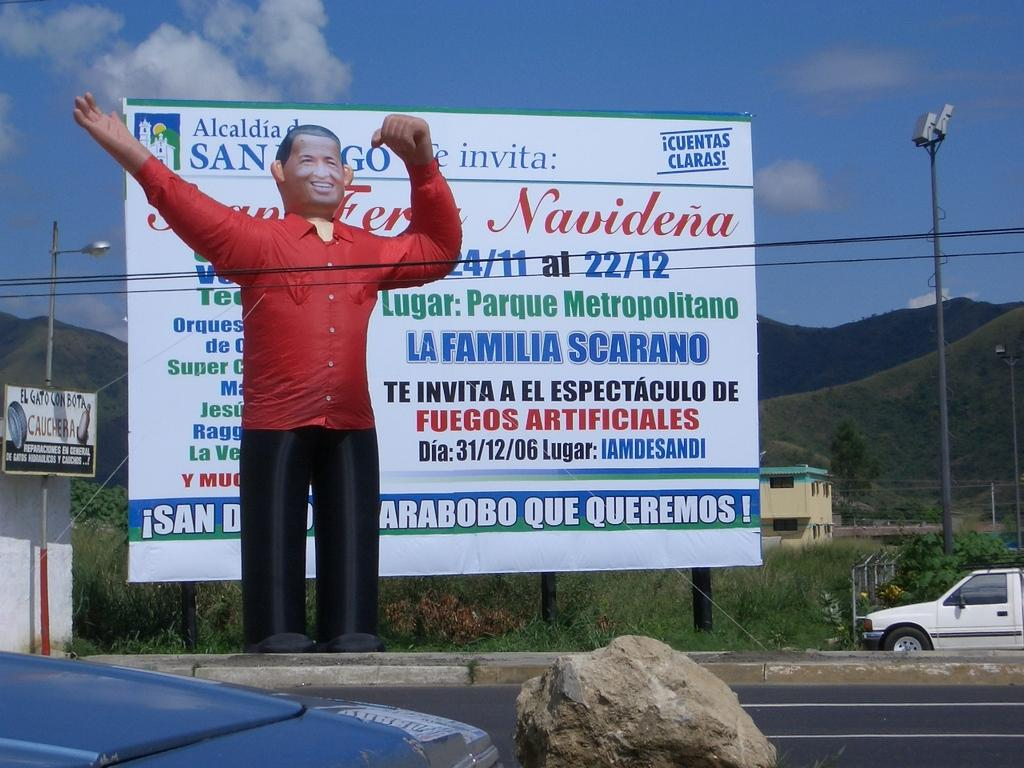<image>
Present a compact description of the photo's key features. A large sign on the side of the road has Navidena in red letters. 